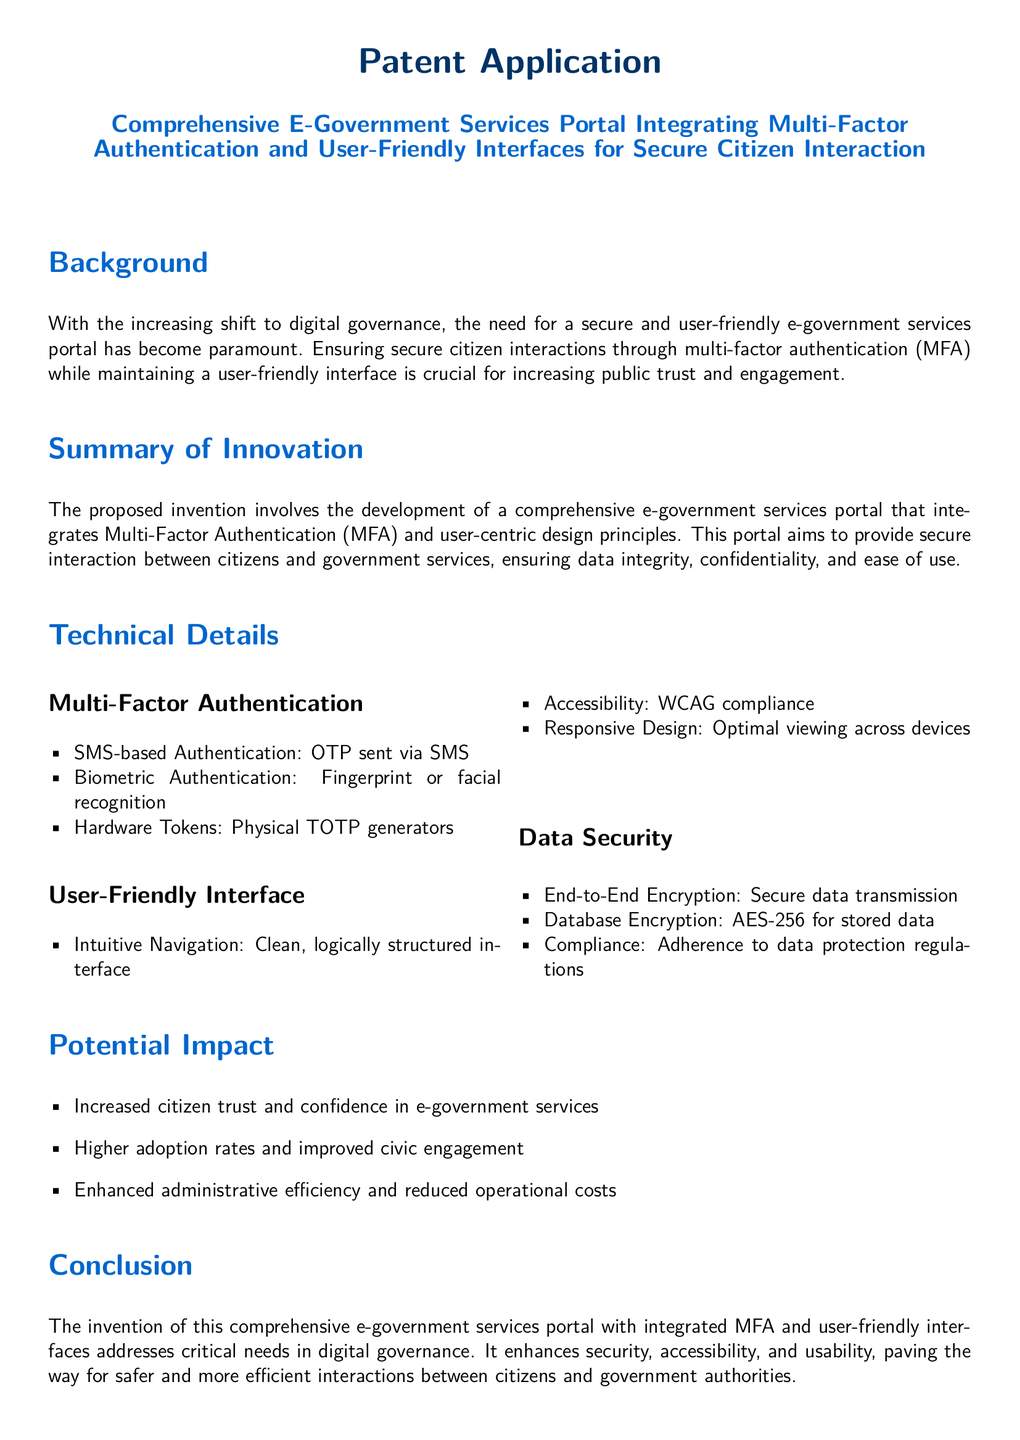What is the title of the patent application? The title is the primary heading of the document which describes the subject matter of the patent.
Answer: Comprehensive E-Government Services Portal Integrating Multi-Factor Authentication and User-Friendly Interfaces for Secure Citizen Interaction What are the three types of Multi-Factor Authentication listed? The document outlines specific methods of authentication under the technical details section.
Answer: SMS-based Authentication, Biometric Authentication, Hardware Tokens What encryption standard is mentioned for database encryption? It specifies the method to protect stored data within the technical details section.
Answer: AES-256 What is one potential impact of the proposed portal? This is listed as a benefit in the impact section of the document.
Answer: Increased citizen trust and confidence in e-government services Which compliance standard is mentioned for accessibility? This detail relates to making sure the portal meets certain guidelines in the document.
Answer: WCAG compliance What does MFA stand for? This acronym is first introduced in the summary of innovation and referenced later in the document.
Answer: Multi-Factor Authentication What type of design principle is emphasized in the user interface section? The user-friendly interface section highlights important aspects of the design approach in the document.
Answer: User-centric design principles What is the primary objective of the proposed e-government services portal? This objective is outlined in the summary of innovation.
Answer: To provide secure interaction between citizens and government services 